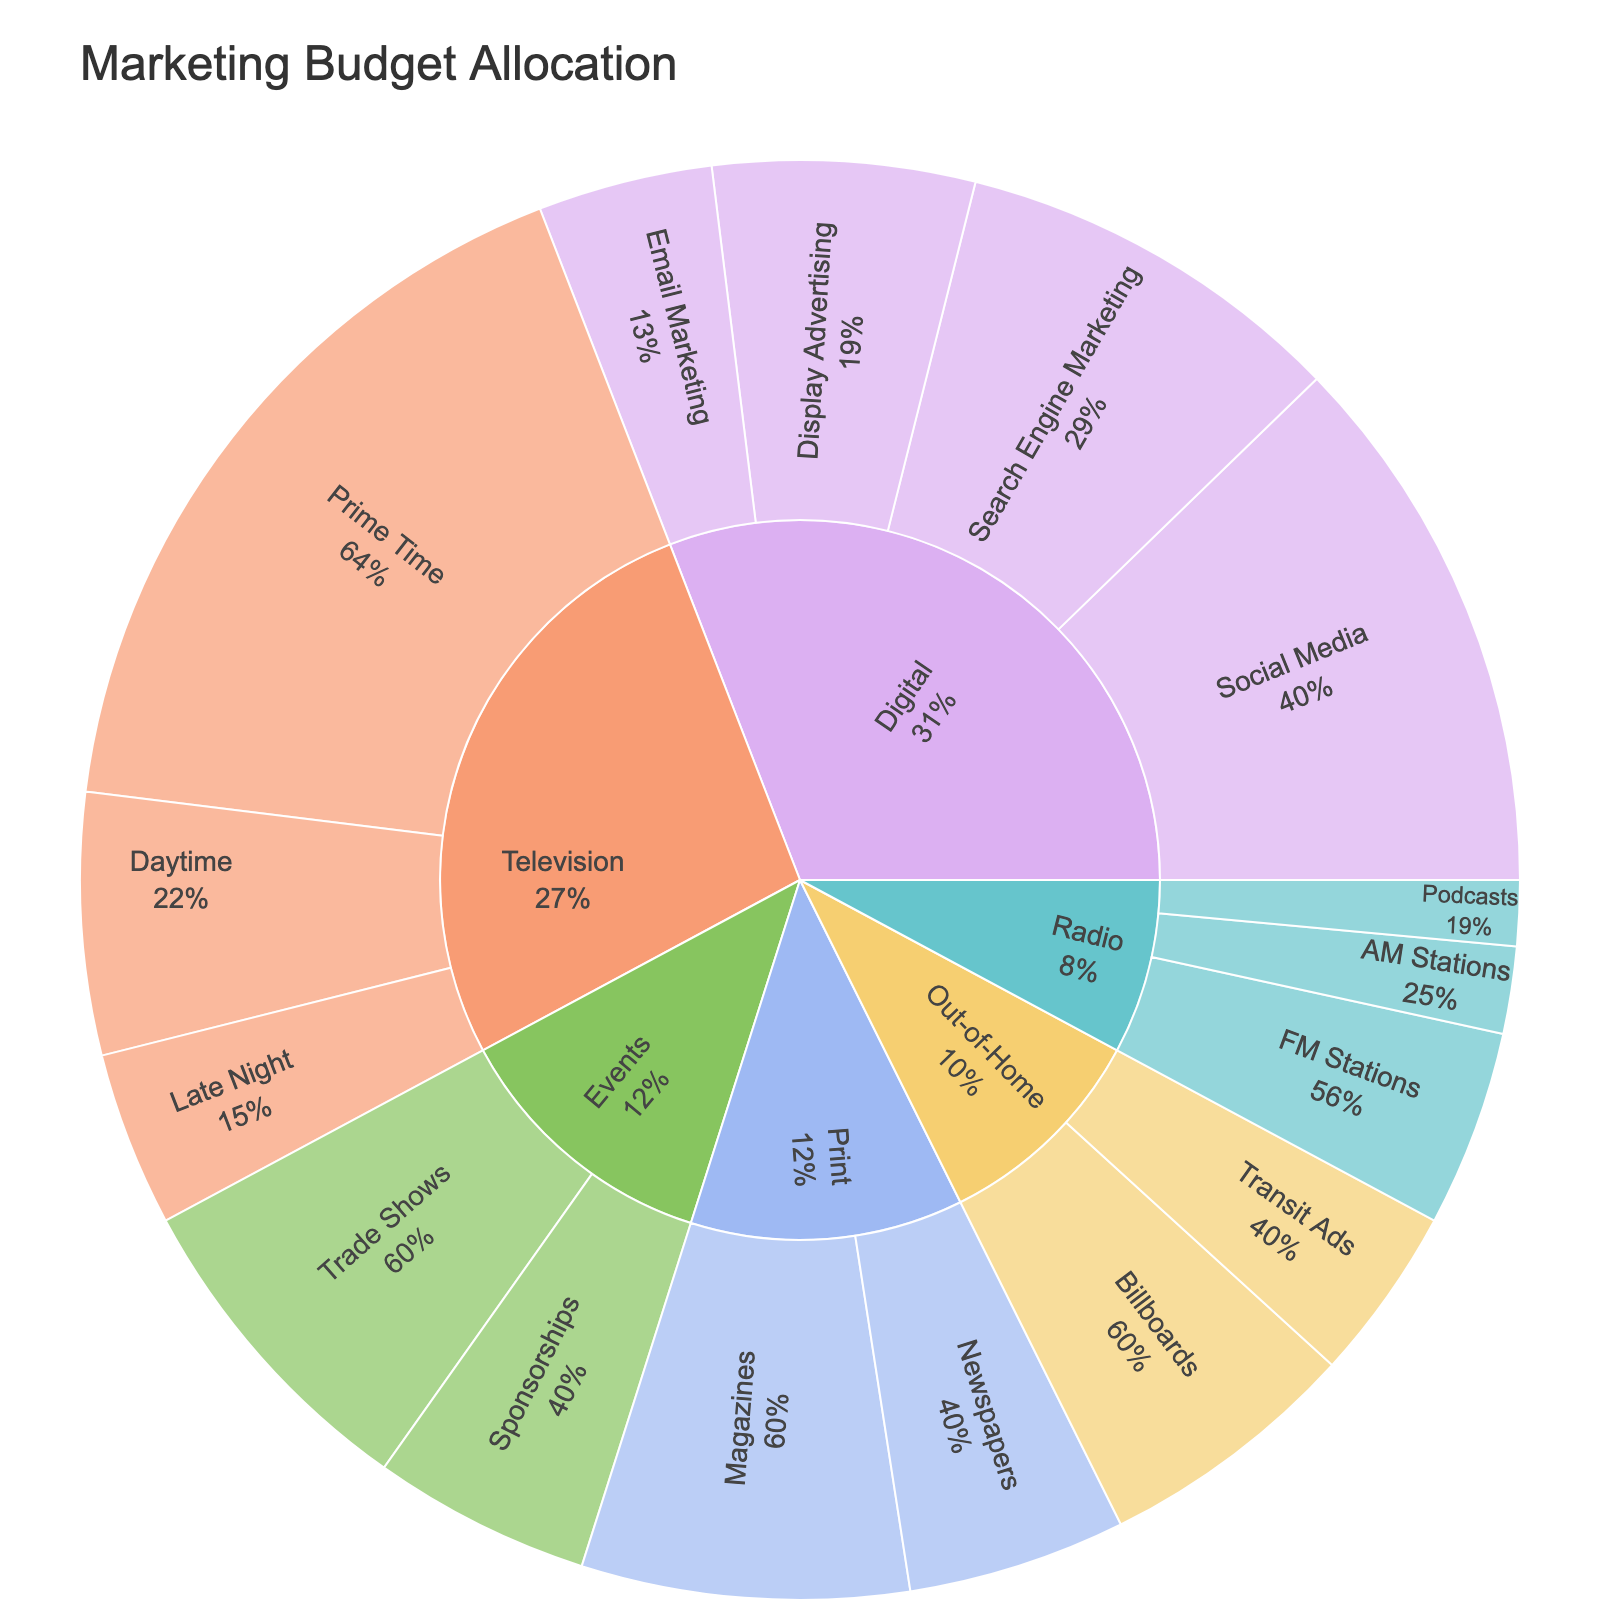What's the title of the figure? The title of the figure is displayed at the top and usually provides a brief description of what the figure represents.
Answer: Marketing Budget Allocation Which channel has the highest budget overall? By looking at the overall size of the segments, the largest segment usually stands out visually. In this case, "Television" has the largest segment, indicating it has the highest budget.
Answer: Television What percentage of the Digital budget is allocated to Social Media? First, identify the total budget for Digital by summing up all subchannel budgets under Digital. Then, find the budget for Social Media within Digital. Finally, divide the Social Media budget by the total Digital budget and convert it to a percentage. Social Media budget: $2,500,000; Total Digital budget: $2,500,000 + $1,800,000 + $1,200,000 + $800,000 = $6,300,000. Percentage: ($2,500,000 / $6,300,000) * 100 ≈ 39.68%
Answer: 39.68% Compare the budget allocated to Prime Time Television and Trade Shows. Which one is higher and by how much? Locate the values for both Prime Time Television ($3,500,000) and Trade Shows ($1,500,000). Subtract the smaller budget from the larger budget. Difference: $3,500,000 - $1,500,000 = $2,000,000.
Answer: Prime Time Television is higher by $2,000,000 What is the total budget allocated to Print channels? Add the budget amounts for Magazines ($1,500,000) and Newspapers ($1,000,000). Sum: $1,500,000 + $1,000,000 = $2,500,000.
Answer: $2,500,000 How much budget is allocated to Radio channels in total? Sum up the budgets for all sub-channels within Radio: FM Stations ($900,000), AM Stations ($400,000), Podcasts ($300,000). Total: $900,000 + $400,000 + $300,000 = $1,600,000.
Answer: $1,600,000 What percentage of the total marketing budget is allocated to Out-of-Home channels? First, find the total marketing budget by summing the budgets for all channels. Total budget: $2,500,000 (Social Media) + $1,800,000 (Search Engine Marketing) + $1,200,000 (Display Advertising) + $800,000 (Email Marketing) + $3,500,000 (Prime Time Television) + $1,200,000 (Daytime Television) + $800,000 (Late Night Television) + $1,500,000 (Magazines) + $1,000,000 (Newspapers) + $1,200,000 (Billboards) + $800,000 (Transit Ads) + $900,000 (FM Stations) + $400,000 (AM Stations) + $300,000 (Podcasts) + $1,500,000 (Trade Shows) + $1,000,000 (Sponsorships) = $19,400,000. Then, find the total Out-of-Home budget: $1,200,000 (Billboards) + $800,000 (Transit Ads) = $2,000,000. Percentage: ($2,000,000 / $19,400,000) * 100 ≈ 10.31%.
Answer: 10.31% Which sub-channel within Events has a higher budget, and what is its proportion of the total Events budget? Compare the budgets for Trade Shows ($1,500,000) and Sponsorships ($1,000,000). Trade Shows have a higher budget. To find the proportion of the total Events budget ($2,500,000), calculate ($1,500,000 / $2,500,000) * 100 = 60%.
Answer: Trade Shows, 60% What is the total marketing budget allocated? Sum up all the individual subchannel budgets listed in the data. Calculation: $2,500,000 + $1,800,000 + $1,200,000 + $800,000 + $3,500,000 + $1,200,000 + $800,000 + $1,500,000 + $1,000,000 + $1,200,000 + $800,000 + $900,000 + $400,000 + $300,000 + $1,500,000 + $1,000,000 = $19,400,000.
Answer: $19,400,000 